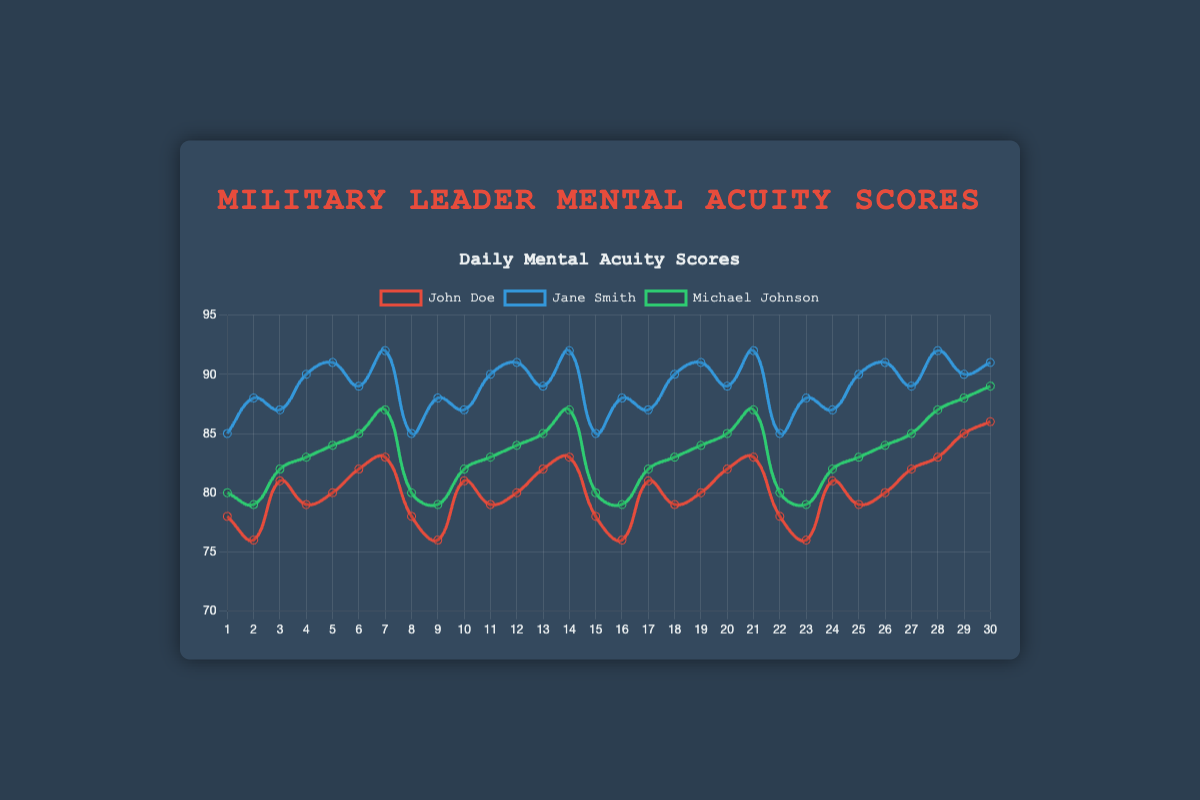What is the average score of John Doe over the training period? To get the average, sum up all of John Doe's scores and divide by the number of days. The sum is (78 + 76 + 81 + 79 + 80 + 82 + 83 + 78 + 76 + 81 + 79 + 80 + 82 + 83 + 78 + 76 + 81 + 79 + 80 + 82 + 83 + 78 + 76 + 81 + 79 + 80 + 82 + 83 + 85 + 86) = 2431. Dividing by 30 days gives 2431/30 = 81.03.
Answer: 81.03 Who had the highest mental acuity score on day 10? On day 10, the scores were: John Doe (81), Jane Smith (87), and Michael Johnson (82). The highest score is 87 by Jane Smith.
Answer: Jane Smith Between which two days did Michael Johnson's score increase the most? To find this, compare the differences between consecutive days for Michael Johnson. The largest increase occurs between day 19 (84) and day 20 (85). The difference is 85 - 84 = 1.
Answer: Day 19 and Day 20 Which leader had the most consistent scores (least variation) throughout the training period? Consistency can be measured as the smallest range of scores (max score - min score). Jane Smith's scores range from 85 to 92, Michael Johnson's from 79 to 89, and John Doe's from 76 to 86. Jane Smith's range is 7, Michael Johnson's is 10, and John Doe's is 10. Thus, Jane Smith had the least variation.
Answer: Jane Smith What is the combined total score for all leaders on day 15? The scores on day 15 are: John Doe (78), Jane Smith (85), and Michael Johnson (80). The combined total is 78 + 85 + 80 = 243.
Answer: 243 How many times did Jane Smith score 90 or above during the training period? Jane Smith scored above 90 on days 4, 5, 7, 11, 14, 19, 25, 26, 28, and 30. This totals 10 times.
Answer: 10 times What is the difference in the score of John Doe between the final day and the initial day? On day 30, John Doe's score is 86. On day 1, it was 78. The difference is 86 - 78 = 8.
Answer: 8 Which leader had the highest peak score, and what was it? The scores peaked as follows: John Doe (86), Jane Smith (92), Michael Johnson (89). The highest is Jane Smith's 92.
Answer: Jane Smith, 92 What is the median value of Michael Johnson's scores over the training period? Arrange Michael Johnson's 30 scores in ascending order and find the middle value. If the number of scores is even, the median is the average of the two middle values. Scores are 79, 79, 79, 79, 80, 80, 80, 82, 82, 82, 83, 83, 83, 84, 84, 84, 85, 85, 85, 87, 87, 87, 88, 88, 89, 89, 89, 89, 91, 92. The middle two scores are the 15th (84) and 16th (84), so the median is 84.
Answer: 84 